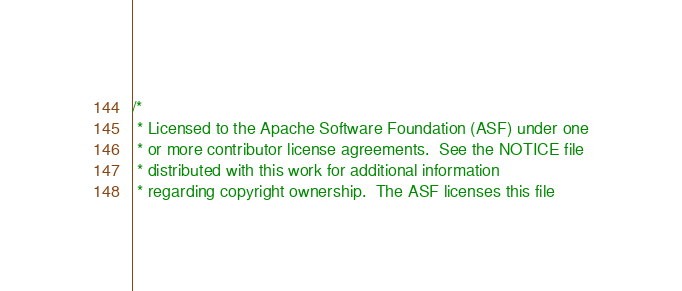<code> <loc_0><loc_0><loc_500><loc_500><_C++_>/*
 * Licensed to the Apache Software Foundation (ASF) under one
 * or more contributor license agreements.  See the NOTICE file
 * distributed with this work for additional information
 * regarding copyright ownership.  The ASF licenses this file</code> 